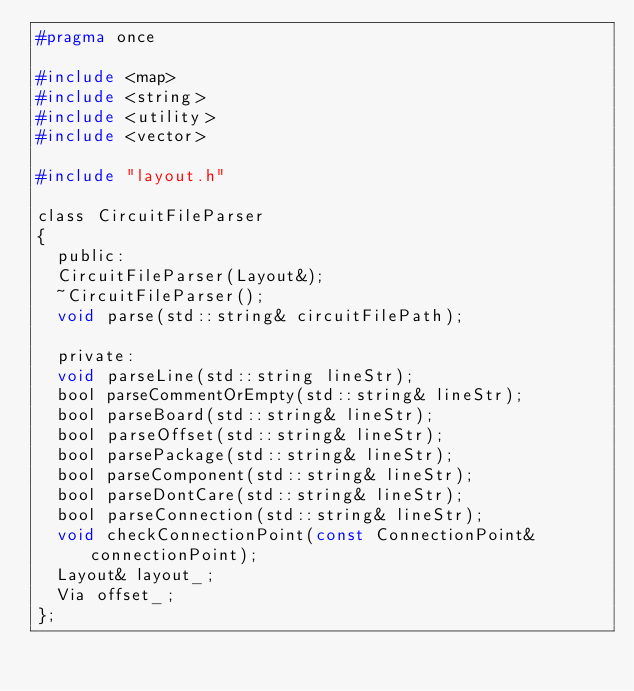<code> <loc_0><loc_0><loc_500><loc_500><_C_>#pragma once

#include <map>
#include <string>
#include <utility>
#include <vector>

#include "layout.h"

class CircuitFileParser
{
  public:
  CircuitFileParser(Layout&);
  ~CircuitFileParser();
  void parse(std::string& circuitFilePath);

  private:
  void parseLine(std::string lineStr);
  bool parseCommentOrEmpty(std::string& lineStr);
  bool parseBoard(std::string& lineStr);
  bool parseOffset(std::string& lineStr);
  bool parsePackage(std::string& lineStr);
  bool parseComponent(std::string& lineStr);
  bool parseDontCare(std::string& lineStr);
  bool parseConnection(std::string& lineStr);
  void checkConnectionPoint(const ConnectionPoint& connectionPoint);
  Layout& layout_;
  Via offset_;
};
</code> 